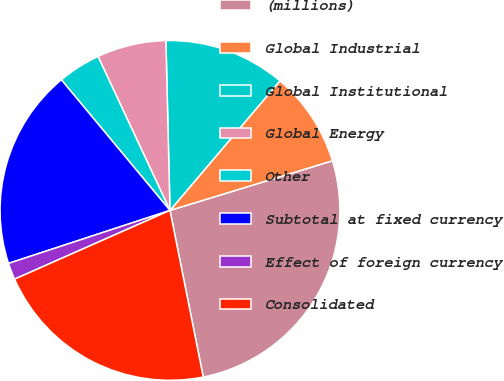Convert chart to OTSL. <chart><loc_0><loc_0><loc_500><loc_500><pie_chart><fcel>(millions)<fcel>Global Industrial<fcel>Global Institutional<fcel>Global Energy<fcel>Other<fcel>Subtotal at fixed currency<fcel>Effect of foreign currency<fcel>Consolidated<nl><fcel>26.58%<fcel>9.08%<fcel>11.58%<fcel>6.58%<fcel>4.08%<fcel>19.01%<fcel>1.58%<fcel>21.51%<nl></chart> 